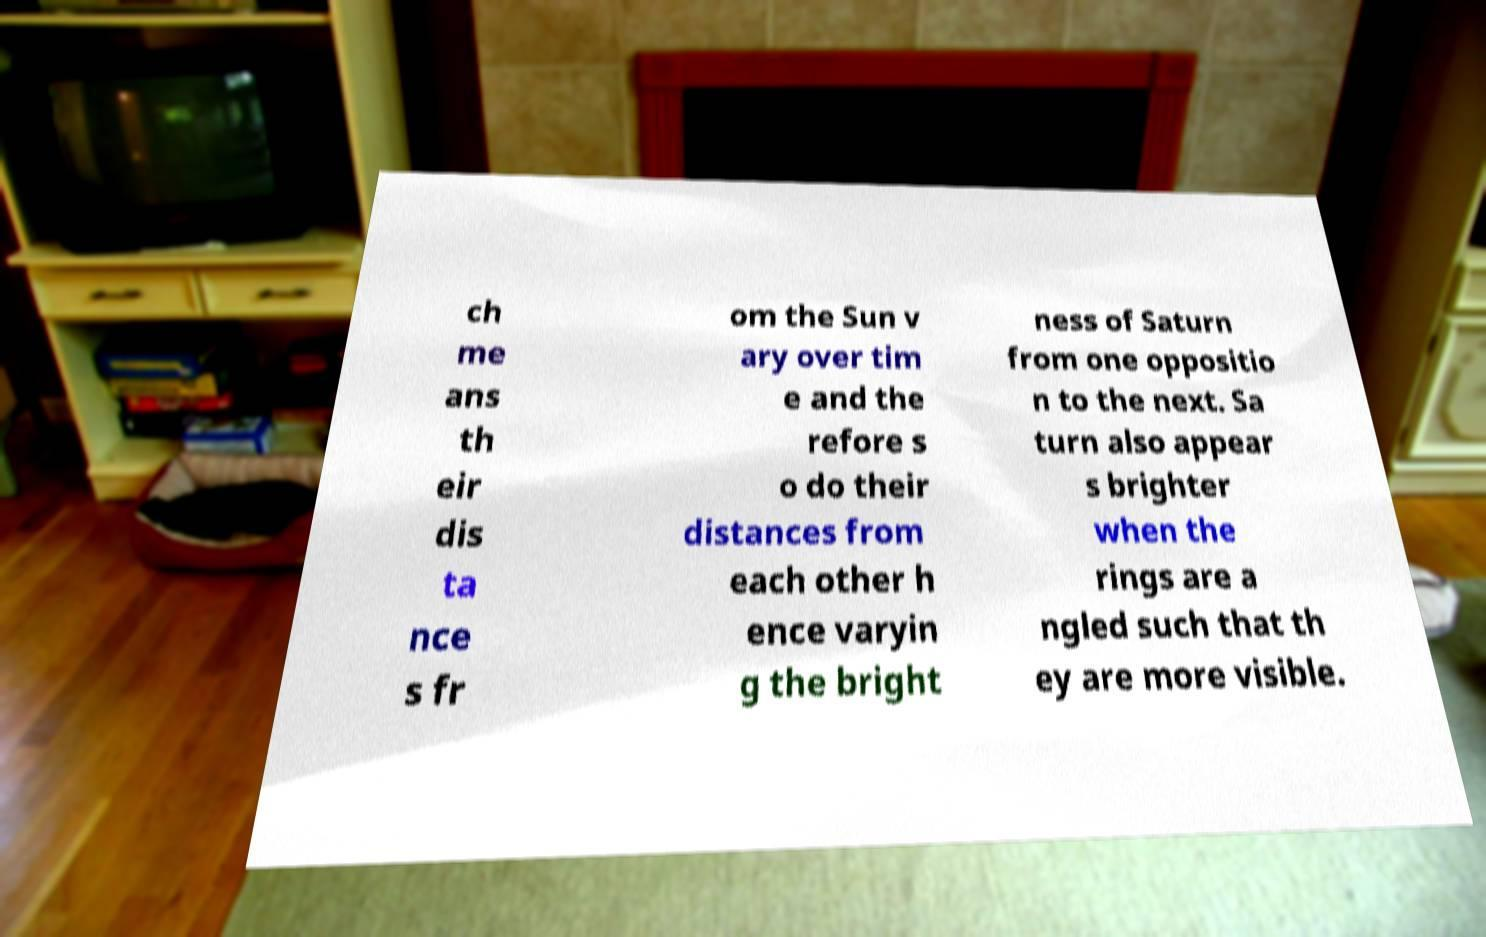Could you assist in decoding the text presented in this image and type it out clearly? ch me ans th eir dis ta nce s fr om the Sun v ary over tim e and the refore s o do their distances from each other h ence varyin g the bright ness of Saturn from one oppositio n to the next. Sa turn also appear s brighter when the rings are a ngled such that th ey are more visible. 